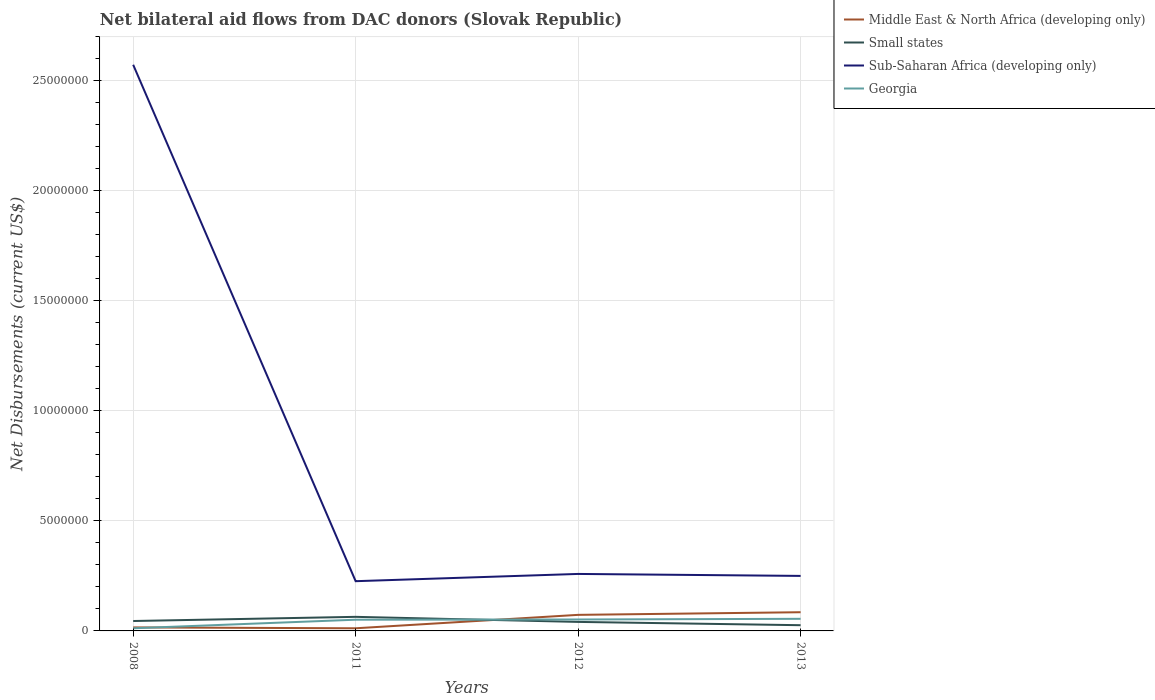How many different coloured lines are there?
Your response must be concise. 4. Does the line corresponding to Georgia intersect with the line corresponding to Small states?
Provide a succinct answer. Yes. Is the number of lines equal to the number of legend labels?
Give a very brief answer. Yes. In which year was the net bilateral aid flows in Middle East & North Africa (developing only) maximum?
Keep it short and to the point. 2011. What is the total net bilateral aid flows in Sub-Saharan Africa (developing only) in the graph?
Offer a terse response. 9.00e+04. What is the difference between the highest and the second highest net bilateral aid flows in Middle East & North Africa (developing only)?
Give a very brief answer. 7.30e+05. What is the difference between the highest and the lowest net bilateral aid flows in Sub-Saharan Africa (developing only)?
Give a very brief answer. 1. How many lines are there?
Your response must be concise. 4. Does the graph contain any zero values?
Offer a terse response. No. Where does the legend appear in the graph?
Offer a terse response. Top right. How many legend labels are there?
Provide a short and direct response. 4. How are the legend labels stacked?
Offer a very short reply. Vertical. What is the title of the graph?
Offer a terse response. Net bilateral aid flows from DAC donors (Slovak Republic). What is the label or title of the X-axis?
Your response must be concise. Years. What is the label or title of the Y-axis?
Keep it short and to the point. Net Disbursements (current US$). What is the Net Disbursements (current US$) of Middle East & North Africa (developing only) in 2008?
Provide a short and direct response. 1.60e+05. What is the Net Disbursements (current US$) in Sub-Saharan Africa (developing only) in 2008?
Provide a short and direct response. 2.57e+07. What is the Net Disbursements (current US$) of Georgia in 2008?
Your answer should be compact. 1.20e+05. What is the Net Disbursements (current US$) of Middle East & North Africa (developing only) in 2011?
Your answer should be very brief. 1.20e+05. What is the Net Disbursements (current US$) of Small states in 2011?
Make the answer very short. 6.40e+05. What is the Net Disbursements (current US$) of Sub-Saharan Africa (developing only) in 2011?
Your response must be concise. 2.26e+06. What is the Net Disbursements (current US$) in Georgia in 2011?
Give a very brief answer. 5.10e+05. What is the Net Disbursements (current US$) of Middle East & North Africa (developing only) in 2012?
Your response must be concise. 7.30e+05. What is the Net Disbursements (current US$) of Sub-Saharan Africa (developing only) in 2012?
Keep it short and to the point. 2.59e+06. What is the Net Disbursements (current US$) in Georgia in 2012?
Provide a short and direct response. 5.20e+05. What is the Net Disbursements (current US$) in Middle East & North Africa (developing only) in 2013?
Offer a very short reply. 8.50e+05. What is the Net Disbursements (current US$) in Small states in 2013?
Ensure brevity in your answer.  2.60e+05. What is the Net Disbursements (current US$) in Sub-Saharan Africa (developing only) in 2013?
Keep it short and to the point. 2.50e+06. Across all years, what is the maximum Net Disbursements (current US$) of Middle East & North Africa (developing only)?
Give a very brief answer. 8.50e+05. Across all years, what is the maximum Net Disbursements (current US$) in Small states?
Offer a very short reply. 6.40e+05. Across all years, what is the maximum Net Disbursements (current US$) of Sub-Saharan Africa (developing only)?
Your answer should be very brief. 2.57e+07. Across all years, what is the minimum Net Disbursements (current US$) of Middle East & North Africa (developing only)?
Ensure brevity in your answer.  1.20e+05. Across all years, what is the minimum Net Disbursements (current US$) in Sub-Saharan Africa (developing only)?
Provide a short and direct response. 2.26e+06. What is the total Net Disbursements (current US$) of Middle East & North Africa (developing only) in the graph?
Your answer should be compact. 1.86e+06. What is the total Net Disbursements (current US$) of Small states in the graph?
Your answer should be compact. 1.76e+06. What is the total Net Disbursements (current US$) of Sub-Saharan Africa (developing only) in the graph?
Offer a very short reply. 3.31e+07. What is the total Net Disbursements (current US$) of Georgia in the graph?
Make the answer very short. 1.70e+06. What is the difference between the Net Disbursements (current US$) in Small states in 2008 and that in 2011?
Provide a short and direct response. -1.90e+05. What is the difference between the Net Disbursements (current US$) in Sub-Saharan Africa (developing only) in 2008 and that in 2011?
Ensure brevity in your answer.  2.35e+07. What is the difference between the Net Disbursements (current US$) of Georgia in 2008 and that in 2011?
Keep it short and to the point. -3.90e+05. What is the difference between the Net Disbursements (current US$) of Middle East & North Africa (developing only) in 2008 and that in 2012?
Offer a terse response. -5.70e+05. What is the difference between the Net Disbursements (current US$) of Small states in 2008 and that in 2012?
Offer a very short reply. 4.00e+04. What is the difference between the Net Disbursements (current US$) in Sub-Saharan Africa (developing only) in 2008 and that in 2012?
Offer a terse response. 2.31e+07. What is the difference between the Net Disbursements (current US$) in Georgia in 2008 and that in 2012?
Your response must be concise. -4.00e+05. What is the difference between the Net Disbursements (current US$) in Middle East & North Africa (developing only) in 2008 and that in 2013?
Keep it short and to the point. -6.90e+05. What is the difference between the Net Disbursements (current US$) in Small states in 2008 and that in 2013?
Your answer should be very brief. 1.90e+05. What is the difference between the Net Disbursements (current US$) in Sub-Saharan Africa (developing only) in 2008 and that in 2013?
Give a very brief answer. 2.32e+07. What is the difference between the Net Disbursements (current US$) in Georgia in 2008 and that in 2013?
Offer a very short reply. -4.30e+05. What is the difference between the Net Disbursements (current US$) in Middle East & North Africa (developing only) in 2011 and that in 2012?
Give a very brief answer. -6.10e+05. What is the difference between the Net Disbursements (current US$) of Small states in 2011 and that in 2012?
Your answer should be compact. 2.30e+05. What is the difference between the Net Disbursements (current US$) of Sub-Saharan Africa (developing only) in 2011 and that in 2012?
Make the answer very short. -3.30e+05. What is the difference between the Net Disbursements (current US$) of Middle East & North Africa (developing only) in 2011 and that in 2013?
Provide a short and direct response. -7.30e+05. What is the difference between the Net Disbursements (current US$) of Small states in 2011 and that in 2013?
Your answer should be compact. 3.80e+05. What is the difference between the Net Disbursements (current US$) of Sub-Saharan Africa (developing only) in 2012 and that in 2013?
Offer a very short reply. 9.00e+04. What is the difference between the Net Disbursements (current US$) in Georgia in 2012 and that in 2013?
Offer a terse response. -3.00e+04. What is the difference between the Net Disbursements (current US$) of Middle East & North Africa (developing only) in 2008 and the Net Disbursements (current US$) of Small states in 2011?
Give a very brief answer. -4.80e+05. What is the difference between the Net Disbursements (current US$) in Middle East & North Africa (developing only) in 2008 and the Net Disbursements (current US$) in Sub-Saharan Africa (developing only) in 2011?
Provide a succinct answer. -2.10e+06. What is the difference between the Net Disbursements (current US$) in Middle East & North Africa (developing only) in 2008 and the Net Disbursements (current US$) in Georgia in 2011?
Ensure brevity in your answer.  -3.50e+05. What is the difference between the Net Disbursements (current US$) in Small states in 2008 and the Net Disbursements (current US$) in Sub-Saharan Africa (developing only) in 2011?
Make the answer very short. -1.81e+06. What is the difference between the Net Disbursements (current US$) of Sub-Saharan Africa (developing only) in 2008 and the Net Disbursements (current US$) of Georgia in 2011?
Keep it short and to the point. 2.52e+07. What is the difference between the Net Disbursements (current US$) in Middle East & North Africa (developing only) in 2008 and the Net Disbursements (current US$) in Small states in 2012?
Keep it short and to the point. -2.50e+05. What is the difference between the Net Disbursements (current US$) in Middle East & North Africa (developing only) in 2008 and the Net Disbursements (current US$) in Sub-Saharan Africa (developing only) in 2012?
Offer a very short reply. -2.43e+06. What is the difference between the Net Disbursements (current US$) of Middle East & North Africa (developing only) in 2008 and the Net Disbursements (current US$) of Georgia in 2012?
Your answer should be compact. -3.60e+05. What is the difference between the Net Disbursements (current US$) in Small states in 2008 and the Net Disbursements (current US$) in Sub-Saharan Africa (developing only) in 2012?
Offer a very short reply. -2.14e+06. What is the difference between the Net Disbursements (current US$) in Small states in 2008 and the Net Disbursements (current US$) in Georgia in 2012?
Provide a succinct answer. -7.00e+04. What is the difference between the Net Disbursements (current US$) of Sub-Saharan Africa (developing only) in 2008 and the Net Disbursements (current US$) of Georgia in 2012?
Your response must be concise. 2.52e+07. What is the difference between the Net Disbursements (current US$) of Middle East & North Africa (developing only) in 2008 and the Net Disbursements (current US$) of Sub-Saharan Africa (developing only) in 2013?
Your answer should be very brief. -2.34e+06. What is the difference between the Net Disbursements (current US$) of Middle East & North Africa (developing only) in 2008 and the Net Disbursements (current US$) of Georgia in 2013?
Provide a succinct answer. -3.90e+05. What is the difference between the Net Disbursements (current US$) of Small states in 2008 and the Net Disbursements (current US$) of Sub-Saharan Africa (developing only) in 2013?
Provide a succinct answer. -2.05e+06. What is the difference between the Net Disbursements (current US$) in Small states in 2008 and the Net Disbursements (current US$) in Georgia in 2013?
Provide a short and direct response. -1.00e+05. What is the difference between the Net Disbursements (current US$) in Sub-Saharan Africa (developing only) in 2008 and the Net Disbursements (current US$) in Georgia in 2013?
Provide a short and direct response. 2.52e+07. What is the difference between the Net Disbursements (current US$) of Middle East & North Africa (developing only) in 2011 and the Net Disbursements (current US$) of Small states in 2012?
Your answer should be compact. -2.90e+05. What is the difference between the Net Disbursements (current US$) in Middle East & North Africa (developing only) in 2011 and the Net Disbursements (current US$) in Sub-Saharan Africa (developing only) in 2012?
Provide a short and direct response. -2.47e+06. What is the difference between the Net Disbursements (current US$) in Middle East & North Africa (developing only) in 2011 and the Net Disbursements (current US$) in Georgia in 2012?
Ensure brevity in your answer.  -4.00e+05. What is the difference between the Net Disbursements (current US$) of Small states in 2011 and the Net Disbursements (current US$) of Sub-Saharan Africa (developing only) in 2012?
Your response must be concise. -1.95e+06. What is the difference between the Net Disbursements (current US$) in Small states in 2011 and the Net Disbursements (current US$) in Georgia in 2012?
Keep it short and to the point. 1.20e+05. What is the difference between the Net Disbursements (current US$) in Sub-Saharan Africa (developing only) in 2011 and the Net Disbursements (current US$) in Georgia in 2012?
Offer a terse response. 1.74e+06. What is the difference between the Net Disbursements (current US$) of Middle East & North Africa (developing only) in 2011 and the Net Disbursements (current US$) of Sub-Saharan Africa (developing only) in 2013?
Provide a short and direct response. -2.38e+06. What is the difference between the Net Disbursements (current US$) in Middle East & North Africa (developing only) in 2011 and the Net Disbursements (current US$) in Georgia in 2013?
Provide a short and direct response. -4.30e+05. What is the difference between the Net Disbursements (current US$) in Small states in 2011 and the Net Disbursements (current US$) in Sub-Saharan Africa (developing only) in 2013?
Your answer should be very brief. -1.86e+06. What is the difference between the Net Disbursements (current US$) of Small states in 2011 and the Net Disbursements (current US$) of Georgia in 2013?
Your answer should be compact. 9.00e+04. What is the difference between the Net Disbursements (current US$) in Sub-Saharan Africa (developing only) in 2011 and the Net Disbursements (current US$) in Georgia in 2013?
Offer a terse response. 1.71e+06. What is the difference between the Net Disbursements (current US$) in Middle East & North Africa (developing only) in 2012 and the Net Disbursements (current US$) in Sub-Saharan Africa (developing only) in 2013?
Ensure brevity in your answer.  -1.77e+06. What is the difference between the Net Disbursements (current US$) of Small states in 2012 and the Net Disbursements (current US$) of Sub-Saharan Africa (developing only) in 2013?
Ensure brevity in your answer.  -2.09e+06. What is the difference between the Net Disbursements (current US$) of Small states in 2012 and the Net Disbursements (current US$) of Georgia in 2013?
Provide a short and direct response. -1.40e+05. What is the difference between the Net Disbursements (current US$) of Sub-Saharan Africa (developing only) in 2012 and the Net Disbursements (current US$) of Georgia in 2013?
Ensure brevity in your answer.  2.04e+06. What is the average Net Disbursements (current US$) in Middle East & North Africa (developing only) per year?
Your answer should be compact. 4.65e+05. What is the average Net Disbursements (current US$) in Small states per year?
Offer a terse response. 4.40e+05. What is the average Net Disbursements (current US$) of Sub-Saharan Africa (developing only) per year?
Provide a short and direct response. 8.27e+06. What is the average Net Disbursements (current US$) in Georgia per year?
Your response must be concise. 4.25e+05. In the year 2008, what is the difference between the Net Disbursements (current US$) in Middle East & North Africa (developing only) and Net Disbursements (current US$) in Small states?
Offer a terse response. -2.90e+05. In the year 2008, what is the difference between the Net Disbursements (current US$) in Middle East & North Africa (developing only) and Net Disbursements (current US$) in Sub-Saharan Africa (developing only)?
Your answer should be very brief. -2.56e+07. In the year 2008, what is the difference between the Net Disbursements (current US$) in Middle East & North Africa (developing only) and Net Disbursements (current US$) in Georgia?
Ensure brevity in your answer.  4.00e+04. In the year 2008, what is the difference between the Net Disbursements (current US$) in Small states and Net Disbursements (current US$) in Sub-Saharan Africa (developing only)?
Provide a succinct answer. -2.53e+07. In the year 2008, what is the difference between the Net Disbursements (current US$) of Sub-Saharan Africa (developing only) and Net Disbursements (current US$) of Georgia?
Give a very brief answer. 2.56e+07. In the year 2011, what is the difference between the Net Disbursements (current US$) in Middle East & North Africa (developing only) and Net Disbursements (current US$) in Small states?
Your answer should be compact. -5.20e+05. In the year 2011, what is the difference between the Net Disbursements (current US$) of Middle East & North Africa (developing only) and Net Disbursements (current US$) of Sub-Saharan Africa (developing only)?
Ensure brevity in your answer.  -2.14e+06. In the year 2011, what is the difference between the Net Disbursements (current US$) in Middle East & North Africa (developing only) and Net Disbursements (current US$) in Georgia?
Make the answer very short. -3.90e+05. In the year 2011, what is the difference between the Net Disbursements (current US$) in Small states and Net Disbursements (current US$) in Sub-Saharan Africa (developing only)?
Make the answer very short. -1.62e+06. In the year 2011, what is the difference between the Net Disbursements (current US$) in Small states and Net Disbursements (current US$) in Georgia?
Make the answer very short. 1.30e+05. In the year 2011, what is the difference between the Net Disbursements (current US$) in Sub-Saharan Africa (developing only) and Net Disbursements (current US$) in Georgia?
Provide a short and direct response. 1.75e+06. In the year 2012, what is the difference between the Net Disbursements (current US$) of Middle East & North Africa (developing only) and Net Disbursements (current US$) of Sub-Saharan Africa (developing only)?
Your response must be concise. -1.86e+06. In the year 2012, what is the difference between the Net Disbursements (current US$) in Middle East & North Africa (developing only) and Net Disbursements (current US$) in Georgia?
Provide a succinct answer. 2.10e+05. In the year 2012, what is the difference between the Net Disbursements (current US$) in Small states and Net Disbursements (current US$) in Sub-Saharan Africa (developing only)?
Give a very brief answer. -2.18e+06. In the year 2012, what is the difference between the Net Disbursements (current US$) of Sub-Saharan Africa (developing only) and Net Disbursements (current US$) of Georgia?
Make the answer very short. 2.07e+06. In the year 2013, what is the difference between the Net Disbursements (current US$) in Middle East & North Africa (developing only) and Net Disbursements (current US$) in Small states?
Keep it short and to the point. 5.90e+05. In the year 2013, what is the difference between the Net Disbursements (current US$) of Middle East & North Africa (developing only) and Net Disbursements (current US$) of Sub-Saharan Africa (developing only)?
Provide a short and direct response. -1.65e+06. In the year 2013, what is the difference between the Net Disbursements (current US$) of Small states and Net Disbursements (current US$) of Sub-Saharan Africa (developing only)?
Keep it short and to the point. -2.24e+06. In the year 2013, what is the difference between the Net Disbursements (current US$) in Small states and Net Disbursements (current US$) in Georgia?
Provide a short and direct response. -2.90e+05. In the year 2013, what is the difference between the Net Disbursements (current US$) in Sub-Saharan Africa (developing only) and Net Disbursements (current US$) in Georgia?
Make the answer very short. 1.95e+06. What is the ratio of the Net Disbursements (current US$) in Small states in 2008 to that in 2011?
Your response must be concise. 0.7. What is the ratio of the Net Disbursements (current US$) of Sub-Saharan Africa (developing only) in 2008 to that in 2011?
Keep it short and to the point. 11.38. What is the ratio of the Net Disbursements (current US$) in Georgia in 2008 to that in 2011?
Make the answer very short. 0.24. What is the ratio of the Net Disbursements (current US$) of Middle East & North Africa (developing only) in 2008 to that in 2012?
Provide a succinct answer. 0.22. What is the ratio of the Net Disbursements (current US$) in Small states in 2008 to that in 2012?
Keep it short and to the point. 1.1. What is the ratio of the Net Disbursements (current US$) of Sub-Saharan Africa (developing only) in 2008 to that in 2012?
Offer a very short reply. 9.93. What is the ratio of the Net Disbursements (current US$) in Georgia in 2008 to that in 2012?
Your answer should be very brief. 0.23. What is the ratio of the Net Disbursements (current US$) of Middle East & North Africa (developing only) in 2008 to that in 2013?
Provide a short and direct response. 0.19. What is the ratio of the Net Disbursements (current US$) in Small states in 2008 to that in 2013?
Your answer should be compact. 1.73. What is the ratio of the Net Disbursements (current US$) of Sub-Saharan Africa (developing only) in 2008 to that in 2013?
Offer a terse response. 10.29. What is the ratio of the Net Disbursements (current US$) of Georgia in 2008 to that in 2013?
Ensure brevity in your answer.  0.22. What is the ratio of the Net Disbursements (current US$) of Middle East & North Africa (developing only) in 2011 to that in 2012?
Your answer should be compact. 0.16. What is the ratio of the Net Disbursements (current US$) of Small states in 2011 to that in 2012?
Your response must be concise. 1.56. What is the ratio of the Net Disbursements (current US$) of Sub-Saharan Africa (developing only) in 2011 to that in 2012?
Provide a short and direct response. 0.87. What is the ratio of the Net Disbursements (current US$) of Georgia in 2011 to that in 2012?
Your answer should be compact. 0.98. What is the ratio of the Net Disbursements (current US$) of Middle East & North Africa (developing only) in 2011 to that in 2013?
Make the answer very short. 0.14. What is the ratio of the Net Disbursements (current US$) of Small states in 2011 to that in 2013?
Your answer should be compact. 2.46. What is the ratio of the Net Disbursements (current US$) of Sub-Saharan Africa (developing only) in 2011 to that in 2013?
Make the answer very short. 0.9. What is the ratio of the Net Disbursements (current US$) of Georgia in 2011 to that in 2013?
Offer a terse response. 0.93. What is the ratio of the Net Disbursements (current US$) of Middle East & North Africa (developing only) in 2012 to that in 2013?
Your answer should be compact. 0.86. What is the ratio of the Net Disbursements (current US$) of Small states in 2012 to that in 2013?
Your answer should be very brief. 1.58. What is the ratio of the Net Disbursements (current US$) in Sub-Saharan Africa (developing only) in 2012 to that in 2013?
Your answer should be very brief. 1.04. What is the ratio of the Net Disbursements (current US$) in Georgia in 2012 to that in 2013?
Your answer should be very brief. 0.95. What is the difference between the highest and the second highest Net Disbursements (current US$) of Sub-Saharan Africa (developing only)?
Give a very brief answer. 2.31e+07. What is the difference between the highest and the lowest Net Disbursements (current US$) of Middle East & North Africa (developing only)?
Ensure brevity in your answer.  7.30e+05. What is the difference between the highest and the lowest Net Disbursements (current US$) of Small states?
Provide a short and direct response. 3.80e+05. What is the difference between the highest and the lowest Net Disbursements (current US$) in Sub-Saharan Africa (developing only)?
Your response must be concise. 2.35e+07. What is the difference between the highest and the lowest Net Disbursements (current US$) of Georgia?
Your response must be concise. 4.30e+05. 